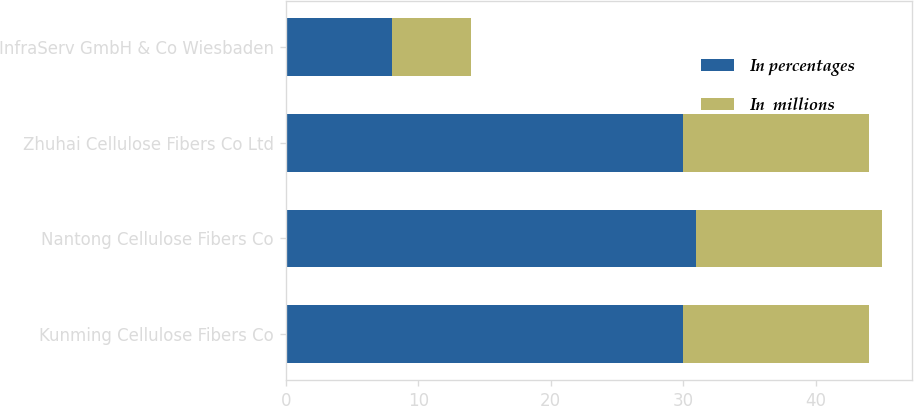Convert chart. <chart><loc_0><loc_0><loc_500><loc_500><stacked_bar_chart><ecel><fcel>Kunming Cellulose Fibers Co<fcel>Nantong Cellulose Fibers Co<fcel>Zhuhai Cellulose Fibers Co Ltd<fcel>InfraServ GmbH & Co Wiesbaden<nl><fcel>In percentages<fcel>30<fcel>31<fcel>30<fcel>8<nl><fcel>In  millions<fcel>14<fcel>14<fcel>14<fcel>6<nl></chart> 